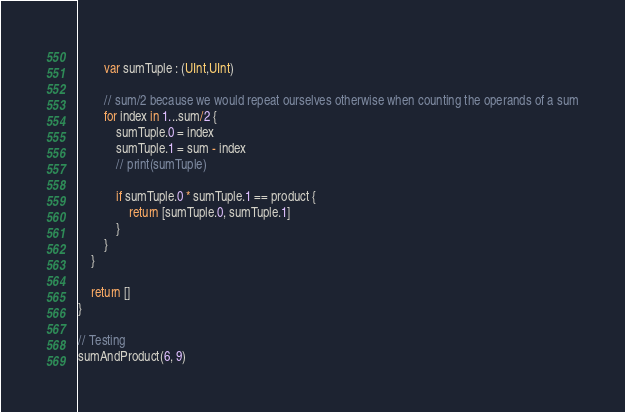Convert code to text. <code><loc_0><loc_0><loc_500><loc_500><_Swift_>        
        var sumTuple : (UInt,UInt)
        
        // sum/2 because we would repeat ourselves otherwise when counting the operands of a sum
        for index in 1...sum/2 {
            sumTuple.0 = index
            sumTuple.1 = sum - index
            // print(sumTuple)
            
            if sumTuple.0 * sumTuple.1 == product {
                return [sumTuple.0, sumTuple.1]
            }
        }
    }
    
    return []
}

// Testing
sumAndProduct(6, 9)
</code> 